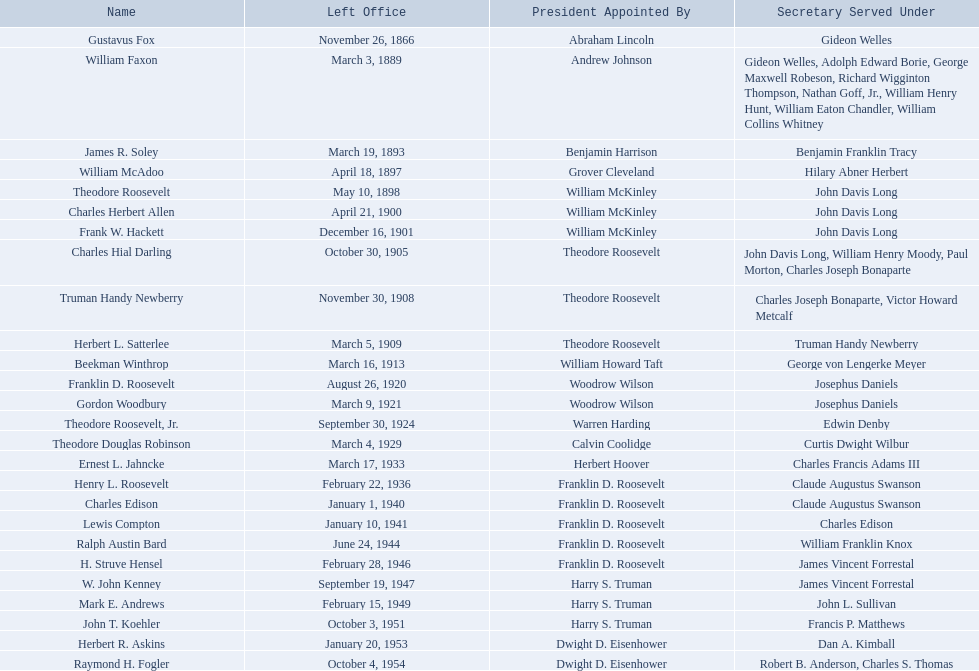Who are all of the assistant secretaries of the navy in the 20th century? Charles Herbert Allen, Frank W. Hackett, Charles Hial Darling, Truman Handy Newberry, Herbert L. Satterlee, Beekman Winthrop, Franklin D. Roosevelt, Gordon Woodbury, Theodore Roosevelt, Jr., Theodore Douglas Robinson, Ernest L. Jahncke, Henry L. Roosevelt, Charles Edison, Lewis Compton, Ralph Austin Bard, H. Struve Hensel, W. John Kenney, Mark E. Andrews, John T. Koehler, Herbert R. Askins, Raymond H. Fogler. What date was assistant secretary of the navy raymond h. fogler appointed? June 22, 1953. What date did assistant secretary of the navy raymond h. fogler leave office? October 4, 1954. What are all the names? Gustavus Fox, William Faxon, James R. Soley, William McAdoo, Theodore Roosevelt, Charles Herbert Allen, Frank W. Hackett, Charles Hial Darling, Truman Handy Newberry, Herbert L. Satterlee, Beekman Winthrop, Franklin D. Roosevelt, Gordon Woodbury, Theodore Roosevelt, Jr., Theodore Douglas Robinson, Ernest L. Jahncke, Henry L. Roosevelt, Charles Edison, Lewis Compton, Ralph Austin Bard, H. Struve Hensel, W. John Kenney, Mark E. Andrews, John T. Koehler, Herbert R. Askins, Raymond H. Fogler. When did they leave office? November 26, 1866, March 3, 1889, March 19, 1893, April 18, 1897, May 10, 1898, April 21, 1900, December 16, 1901, October 30, 1905, November 30, 1908, March 5, 1909, March 16, 1913, August 26, 1920, March 9, 1921, September 30, 1924, March 4, 1929, March 17, 1933, February 22, 1936, January 1, 1940, January 10, 1941, June 24, 1944, February 28, 1946, September 19, 1947, February 15, 1949, October 3, 1951, January 20, 1953, October 4, 1954. And when did raymond h. fogler leave? October 4, 1954. 